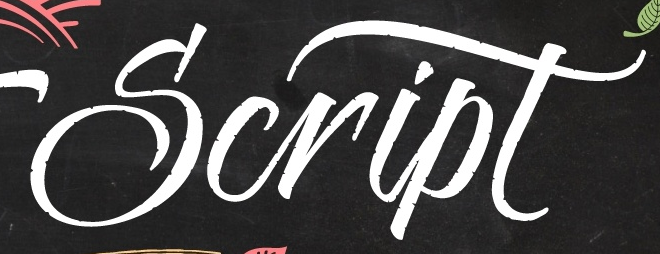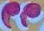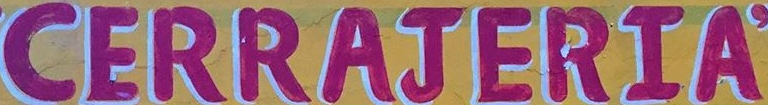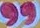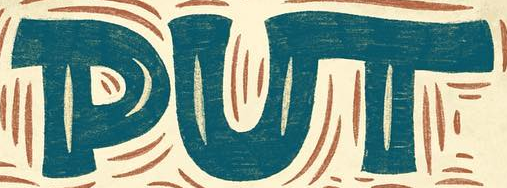Read the text from these images in sequence, separated by a semicolon. Script; "; CERRAJERIA; "; PUT 